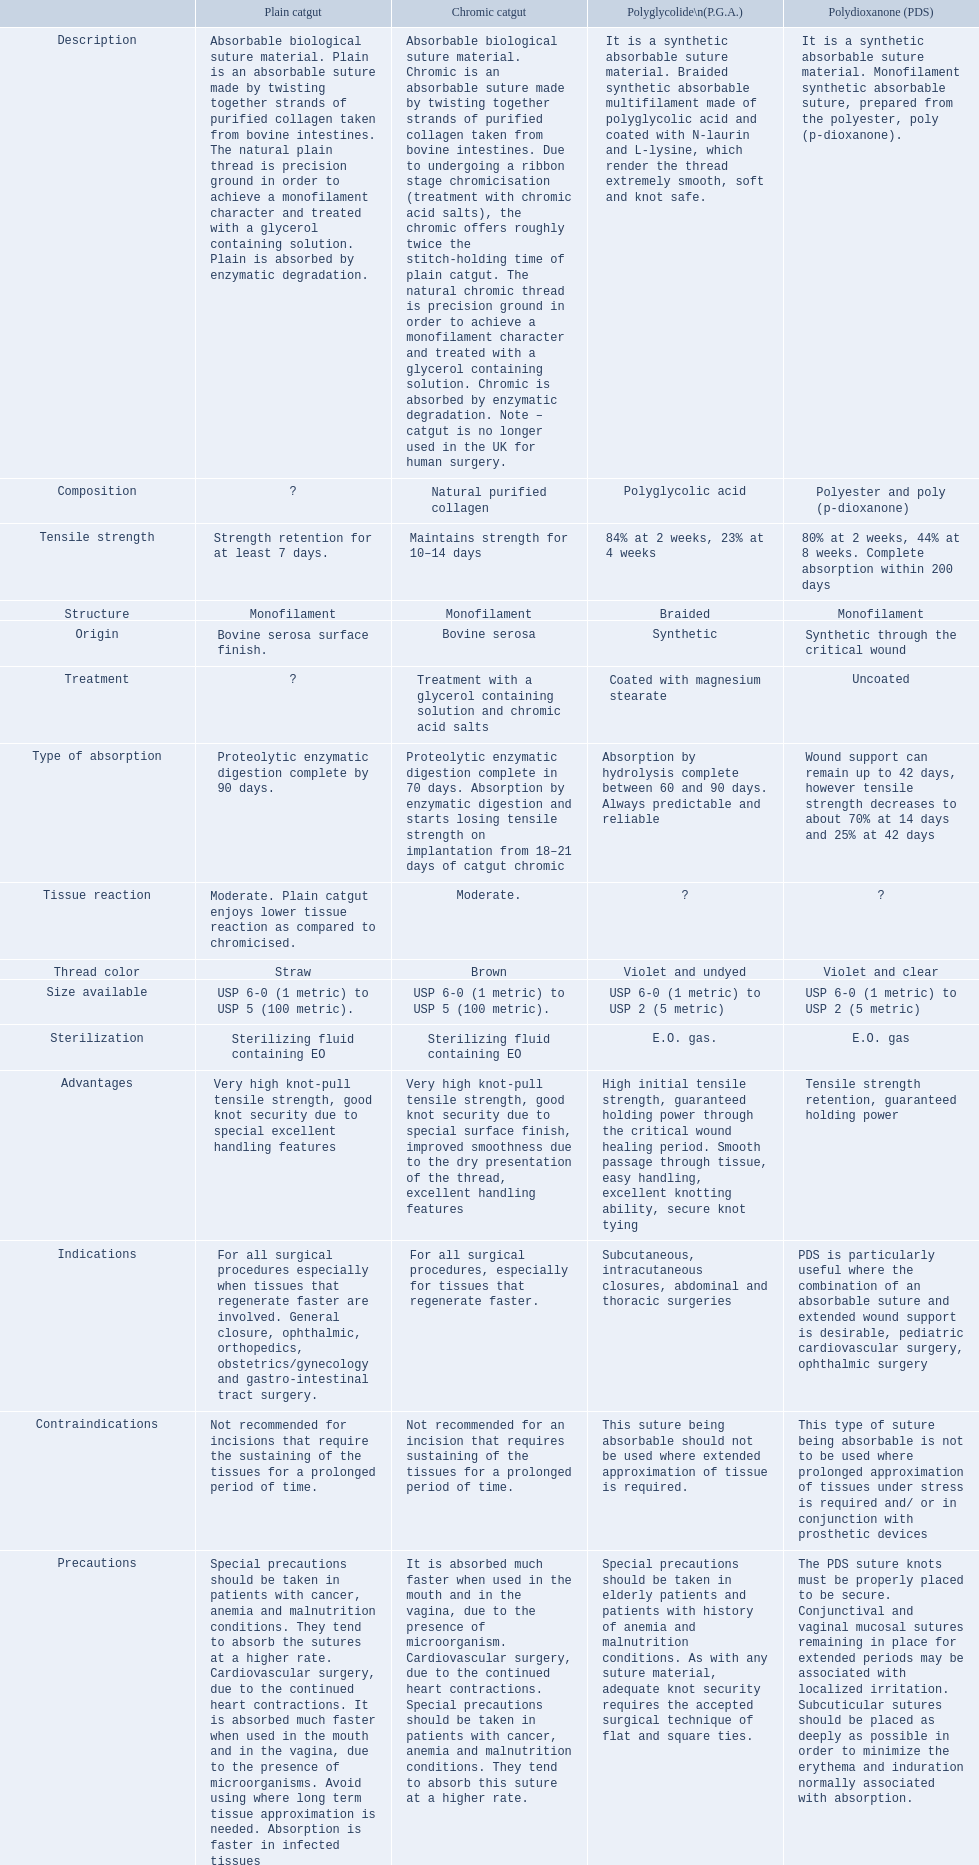Which are the different tensile strengths of the suture materials in the comparison chart? Strength retention for at least 7 days., Maintains strength for 10–14 days, 84% at 2 weeks, 23% at 4 weeks, 80% at 2 weeks, 44% at 8 weeks. Complete absorption within 200 days. Of these, which belongs to plain catgut? Strength retention for at least 7 days. Can you give me this table as a dict? {'header': ['', 'Plain catgut', 'Chromic catgut', 'Polyglycolide\\n(P.G.A.)', 'Polydioxanone (PDS)'], 'rows': [['Description', 'Absorbable biological suture material. Plain is an absorbable suture made by twisting together strands of purified collagen taken from bovine intestines. The natural plain thread is precision ground in order to achieve a monofilament character and treated with a glycerol containing solution. Plain is absorbed by enzymatic degradation.', 'Absorbable biological suture material. Chromic is an absorbable suture made by twisting together strands of purified collagen taken from bovine intestines. Due to undergoing a ribbon stage chromicisation (treatment with chromic acid salts), the chromic offers roughly twice the stitch-holding time of plain catgut. The natural chromic thread is precision ground in order to achieve a monofilament character and treated with a glycerol containing solution. Chromic is absorbed by enzymatic degradation. Note – catgut is no longer used in the UK for human surgery.', 'It is a synthetic absorbable suture material. Braided synthetic absorbable multifilament made of polyglycolic acid and coated with N-laurin and L-lysine, which render the thread extremely smooth, soft and knot safe.', 'It is a synthetic absorbable suture material. Monofilament synthetic absorbable suture, prepared from the polyester, poly (p-dioxanone).'], ['Composition', '?', 'Natural purified collagen', 'Polyglycolic acid', 'Polyester and poly (p-dioxanone)'], ['Tensile strength', 'Strength retention for at least 7 days.', 'Maintains strength for 10–14 days', '84% at 2 weeks, 23% at 4 weeks', '80% at 2 weeks, 44% at 8 weeks. Complete absorption within 200 days'], ['Structure', 'Monofilament', 'Monofilament', 'Braided', 'Monofilament'], ['Origin', 'Bovine serosa surface finish.', 'Bovine serosa', 'Synthetic', 'Synthetic through the critical wound'], ['Treatment', '?', 'Treatment with a glycerol containing solution and chromic acid salts', 'Coated with magnesium stearate', 'Uncoated'], ['Type of absorption', 'Proteolytic enzymatic digestion complete by 90 days.', 'Proteolytic enzymatic digestion complete in 70 days. Absorption by enzymatic digestion and starts losing tensile strength on implantation from 18–21 days of catgut chromic', 'Absorption by hydrolysis complete between 60 and 90 days. Always predictable and reliable', 'Wound support can remain up to 42 days, however tensile strength decreases to about 70% at 14 days and 25% at 42 days'], ['Tissue reaction', 'Moderate. Plain catgut enjoys lower tissue reaction as compared to chromicised.', 'Moderate.', '?', '?'], ['Thread color', 'Straw', 'Brown', 'Violet and undyed', 'Violet and clear'], ['Size available', 'USP 6-0 (1 metric) to USP 5 (100 metric).', 'USP 6-0 (1 metric) to USP 5 (100 metric).', 'USP 6-0 (1 metric) to USP 2 (5 metric)', 'USP 6-0 (1 metric) to USP 2 (5 metric)'], ['Sterilization', 'Sterilizing fluid containing EO', 'Sterilizing fluid containing EO', 'E.O. gas.', 'E.O. gas'], ['Advantages', 'Very high knot-pull tensile strength, good knot security due to special excellent handling features', 'Very high knot-pull tensile strength, good knot security due to special surface finish, improved smoothness due to the dry presentation of the thread, excellent handling features', 'High initial tensile strength, guaranteed holding power through the critical wound healing period. Smooth passage through tissue, easy handling, excellent knotting ability, secure knot tying', 'Tensile strength retention, guaranteed holding power'], ['Indications', 'For all surgical procedures especially when tissues that regenerate faster are involved. General closure, ophthalmic, orthopedics, obstetrics/gynecology and gastro-intestinal tract surgery.', 'For all surgical procedures, especially for tissues that regenerate faster.', 'Subcutaneous, intracutaneous closures, abdominal and thoracic surgeries', 'PDS is particularly useful where the combination of an absorbable suture and extended wound support is desirable, pediatric cardiovascular surgery, ophthalmic surgery'], ['Contraindications', 'Not recommended for incisions that require the sustaining of the tissues for a prolonged period of time.', 'Not recommended for an incision that requires sustaining of the tissues for a prolonged period of time.', 'This suture being absorbable should not be used where extended approximation of tissue is required.', 'This type of suture being absorbable is not to be used where prolonged approximation of tissues under stress is required and/ or in conjunction with prosthetic devices'], ['Precautions', 'Special precautions should be taken in patients with cancer, anemia and malnutrition conditions. They tend to absorb the sutures at a higher rate. Cardiovascular surgery, due to the continued heart contractions. It is absorbed much faster when used in the mouth and in the vagina, due to the presence of microorganisms. Avoid using where long term tissue approximation is needed. Absorption is faster in infected tissues', 'It is absorbed much faster when used in the mouth and in the vagina, due to the presence of microorganism. Cardiovascular surgery, due to the continued heart contractions. Special precautions should be taken in patients with cancer, anemia and malnutrition conditions. They tend to absorb this suture at a higher rate.', 'Special precautions should be taken in elderly patients and patients with history of anemia and malnutrition conditions. As with any suture material, adequate knot security requires the accepted surgical technique of flat and square ties.', 'The PDS suture knots must be properly placed to be secure. Conjunctival and vaginal mucosal sutures remaining in place for extended periods may be associated with localized irritation. Subcuticular sutures should be placed as deeply as possible in order to minimize the erythema and induration normally associated with absorption.']]} What types are included in the suture materials comparison diagram? Description, Composition, Tensile strength, Structure, Origin, Treatment, Type of absorption, Tissue reaction, Thread color, Size available, Sterilization, Advantages, Indications, Contraindications, Precautions. Regarding the tensile strength, which is the least? Strength retention for at least 7 days. Over what period does chronic catgut keep its strength? Maintains strength for 10–14 days. What does plain catgut refer to? Absorbable biological suture material. Plain is an absorbable suture made by twisting together strands of purified collagen taken from bovine intestines. The natural plain thread is precision ground in order to achieve a monofilament character and treated with a glycerol containing solution. Plain is absorbed by enzymatic degradation. For how many days is catgut's strength retained? Strength retention for at least 7 days. 